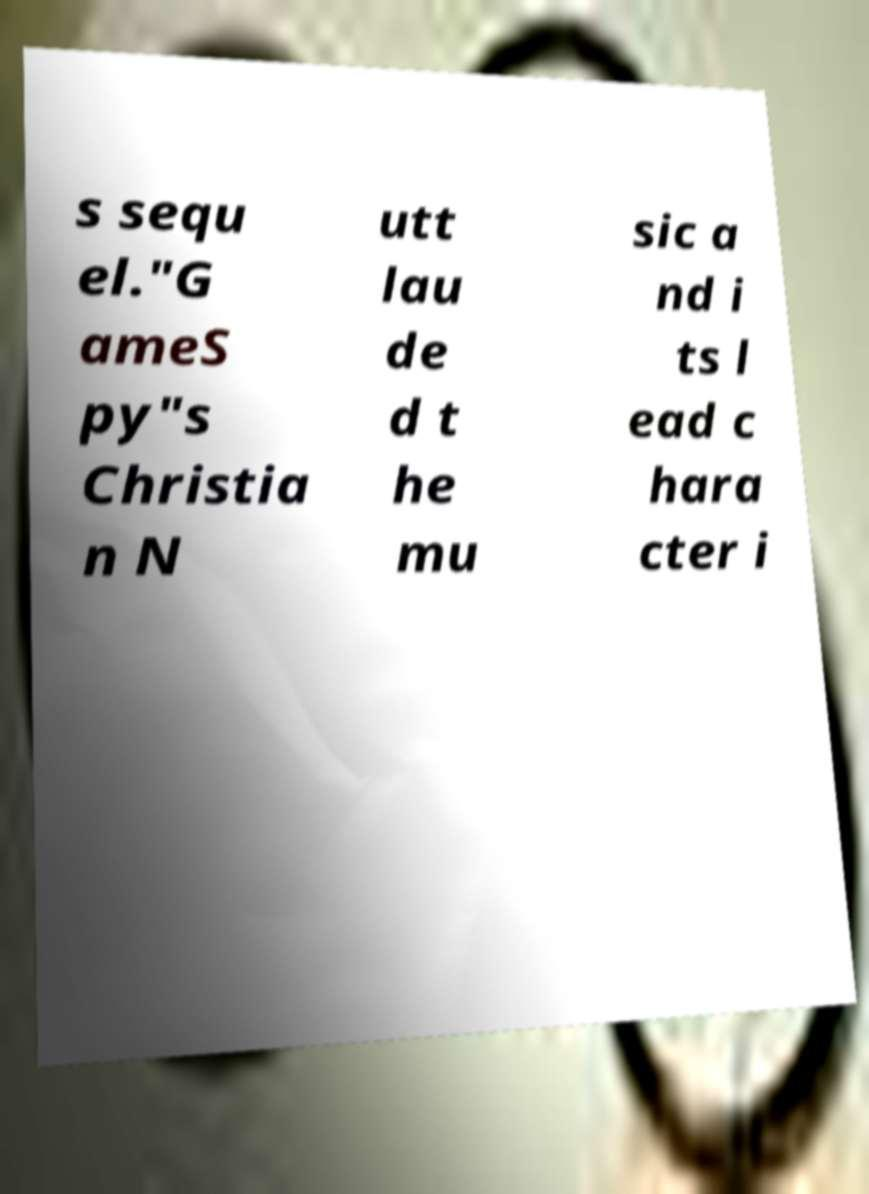Could you extract and type out the text from this image? s sequ el."G ameS py"s Christia n N utt lau de d t he mu sic a nd i ts l ead c hara cter i 